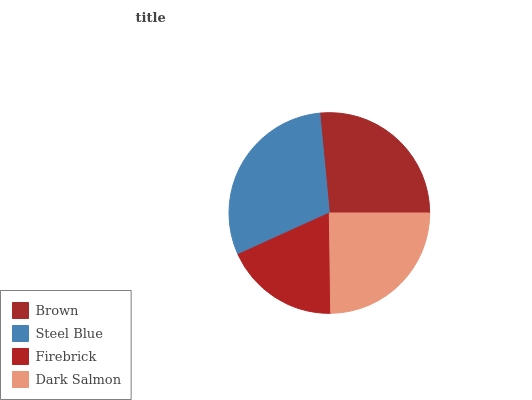Is Firebrick the minimum?
Answer yes or no. Yes. Is Steel Blue the maximum?
Answer yes or no. Yes. Is Steel Blue the minimum?
Answer yes or no. No. Is Firebrick the maximum?
Answer yes or no. No. Is Steel Blue greater than Firebrick?
Answer yes or no. Yes. Is Firebrick less than Steel Blue?
Answer yes or no. Yes. Is Firebrick greater than Steel Blue?
Answer yes or no. No. Is Steel Blue less than Firebrick?
Answer yes or no. No. Is Brown the high median?
Answer yes or no. Yes. Is Dark Salmon the low median?
Answer yes or no. Yes. Is Firebrick the high median?
Answer yes or no. No. Is Steel Blue the low median?
Answer yes or no. No. 